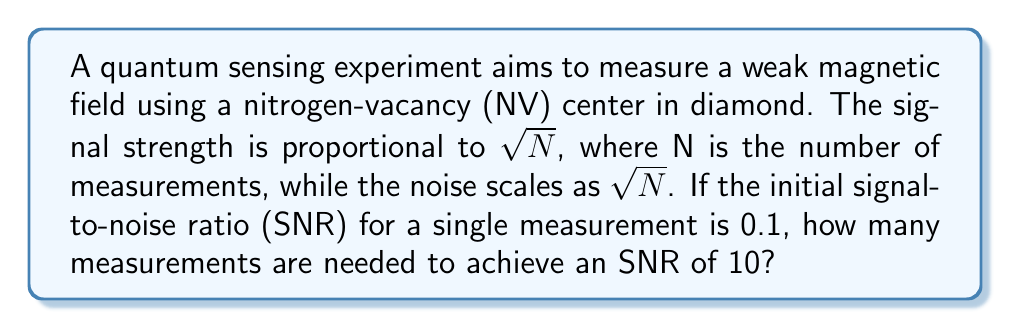Could you help me with this problem? Let's approach this step-by-step:

1) The signal-to-noise ratio (SNR) is defined as:

   $$ SNR = \frac{Signal}{Noise} $$

2) Given information:
   - Initial SNR for a single measurement: $SNR_1 = 0.1$
   - Signal scales as $\sqrt{N}$
   - Noise scales as $\sqrt{N}$
   - Target SNR: $SNR_N = 10$

3) For N measurements, the SNR becomes:

   $$ SNR_N = \frac{Signal \cdot \sqrt{N}}{Noise \cdot \sqrt{N}} = SNR_1 \cdot \sqrt{N} $$

4) We can set up an equation:

   $$ 10 = 0.1 \cdot \sqrt{N} $$

5) Solve for N:

   $$ \sqrt{N} = \frac{10}{0.1} = 100 $$

   $$ N = 100^2 = 10,000 $$

Therefore, 10,000 measurements are needed to achieve an SNR of 10.
Answer: 10,000 measurements 